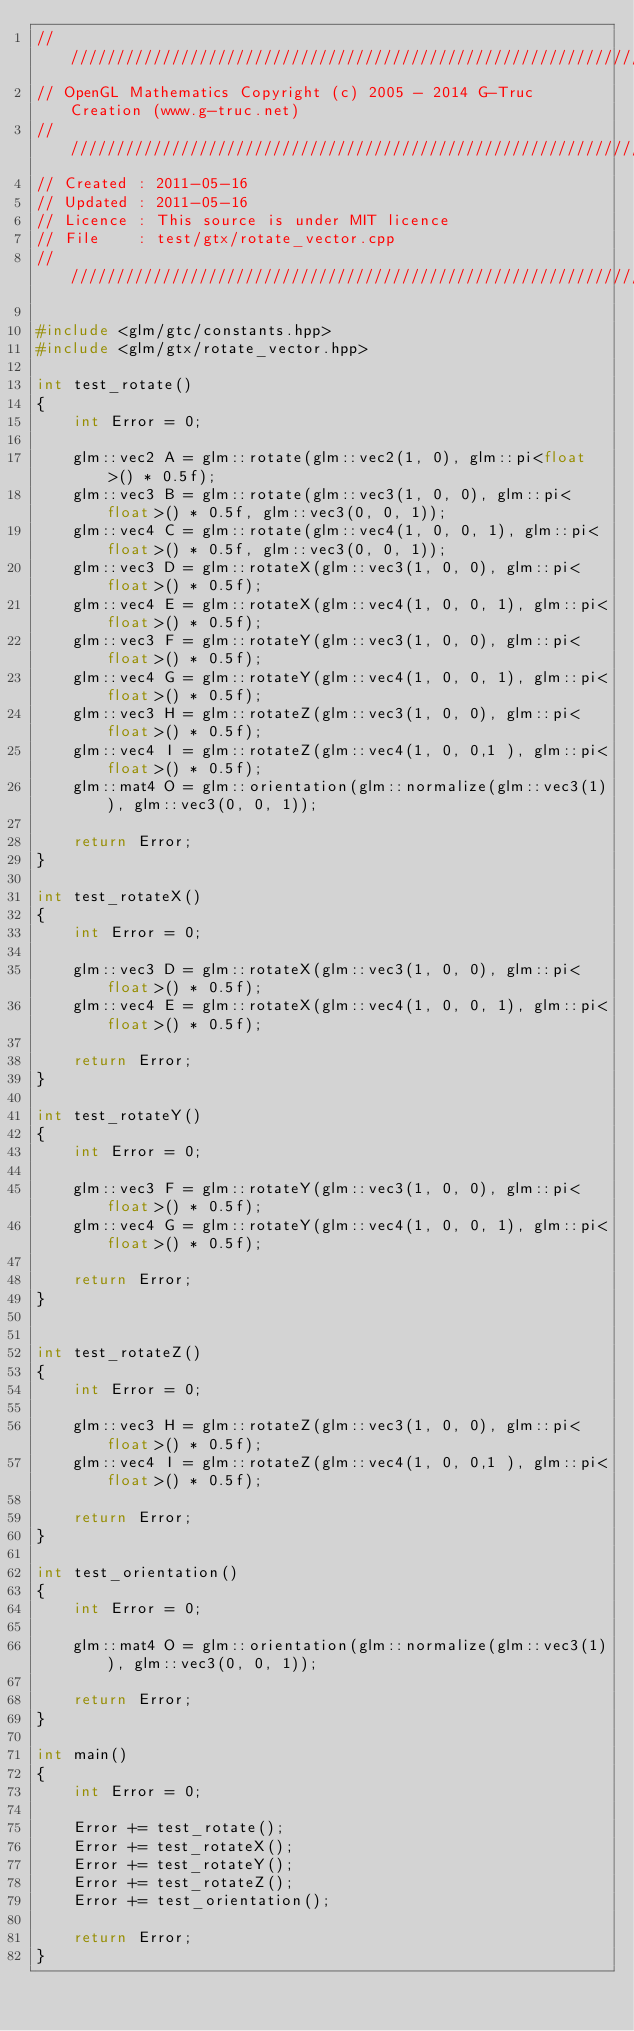Convert code to text. <code><loc_0><loc_0><loc_500><loc_500><_C++_>///////////////////////////////////////////////////////////////////////////////////////////////////
// OpenGL Mathematics Copyright (c) 2005 - 2014 G-Truc Creation (www.g-truc.net)
///////////////////////////////////////////////////////////////////////////////////////////////////
// Created : 2011-05-16
// Updated : 2011-05-16
// Licence : This source is under MIT licence
// File    : test/gtx/rotate_vector.cpp
///////////////////////////////////////////////////////////////////////////////////////////////////

#include <glm/gtc/constants.hpp>
#include <glm/gtx/rotate_vector.hpp>

int test_rotate()
{
	int Error = 0;

	glm::vec2 A = glm::rotate(glm::vec2(1, 0), glm::pi<float>() * 0.5f);
	glm::vec3 B = glm::rotate(glm::vec3(1, 0, 0), glm::pi<float>() * 0.5f, glm::vec3(0, 0, 1));
	glm::vec4 C = glm::rotate(glm::vec4(1, 0, 0, 1), glm::pi<float>() * 0.5f, glm::vec3(0, 0, 1));
	glm::vec3 D = glm::rotateX(glm::vec3(1, 0, 0), glm::pi<float>() * 0.5f);
	glm::vec4 E = glm::rotateX(glm::vec4(1, 0, 0, 1), glm::pi<float>() * 0.5f);
	glm::vec3 F = glm::rotateY(glm::vec3(1, 0, 0), glm::pi<float>() * 0.5f);
	glm::vec4 G = glm::rotateY(glm::vec4(1, 0, 0, 1), glm::pi<float>() * 0.5f);
	glm::vec3 H = glm::rotateZ(glm::vec3(1, 0, 0), glm::pi<float>() * 0.5f);
	glm::vec4 I = glm::rotateZ(glm::vec4(1, 0, 0,1 ), glm::pi<float>() * 0.5f);
	glm::mat4 O = glm::orientation(glm::normalize(glm::vec3(1)), glm::vec3(0, 0, 1));

	return Error;
}

int test_rotateX()
{
	int Error = 0;

	glm::vec3 D = glm::rotateX(glm::vec3(1, 0, 0), glm::pi<float>() * 0.5f);
	glm::vec4 E = glm::rotateX(glm::vec4(1, 0, 0, 1), glm::pi<float>() * 0.5f);

	return Error;
}

int test_rotateY()
{
	int Error = 0;

	glm::vec3 F = glm::rotateY(glm::vec3(1, 0, 0), glm::pi<float>() * 0.5f);
	glm::vec4 G = glm::rotateY(glm::vec4(1, 0, 0, 1), glm::pi<float>() * 0.5f);

	return Error;
}


int test_rotateZ()
{
	int Error = 0;

	glm::vec3 H = glm::rotateZ(glm::vec3(1, 0, 0), glm::pi<float>() * 0.5f);
	glm::vec4 I = glm::rotateZ(glm::vec4(1, 0, 0,1 ), glm::pi<float>() * 0.5f);

	return Error;
}

int test_orientation()
{
	int Error = 0;

	glm::mat4 O = glm::orientation(glm::normalize(glm::vec3(1)), glm::vec3(0, 0, 1));

	return Error;
}

int main()
{
	int Error = 0;

	Error += test_rotate();
	Error += test_rotateX();
	Error += test_rotateY();
	Error += test_rotateZ();
	Error += test_orientation();

	return Error;
}


</code> 